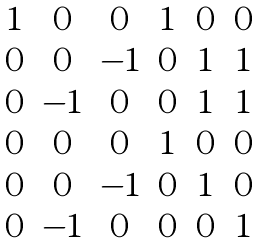Convert formula to latex. <formula><loc_0><loc_0><loc_500><loc_500>\begin{matrix} 1 & 0 & 0 & 1 & 0 & 0 \\ 0 & 0 & - 1 & 0 & 1 & 1 \\ 0 & - 1 & 0 & 0 & 1 & 1 \\ 0 & 0 & 0 & 1 & 0 & 0 \\ 0 & 0 & - 1 & 0 & 1 & 0 \\ 0 & - 1 & 0 & 0 & 0 & 1 \end{matrix}</formula> 